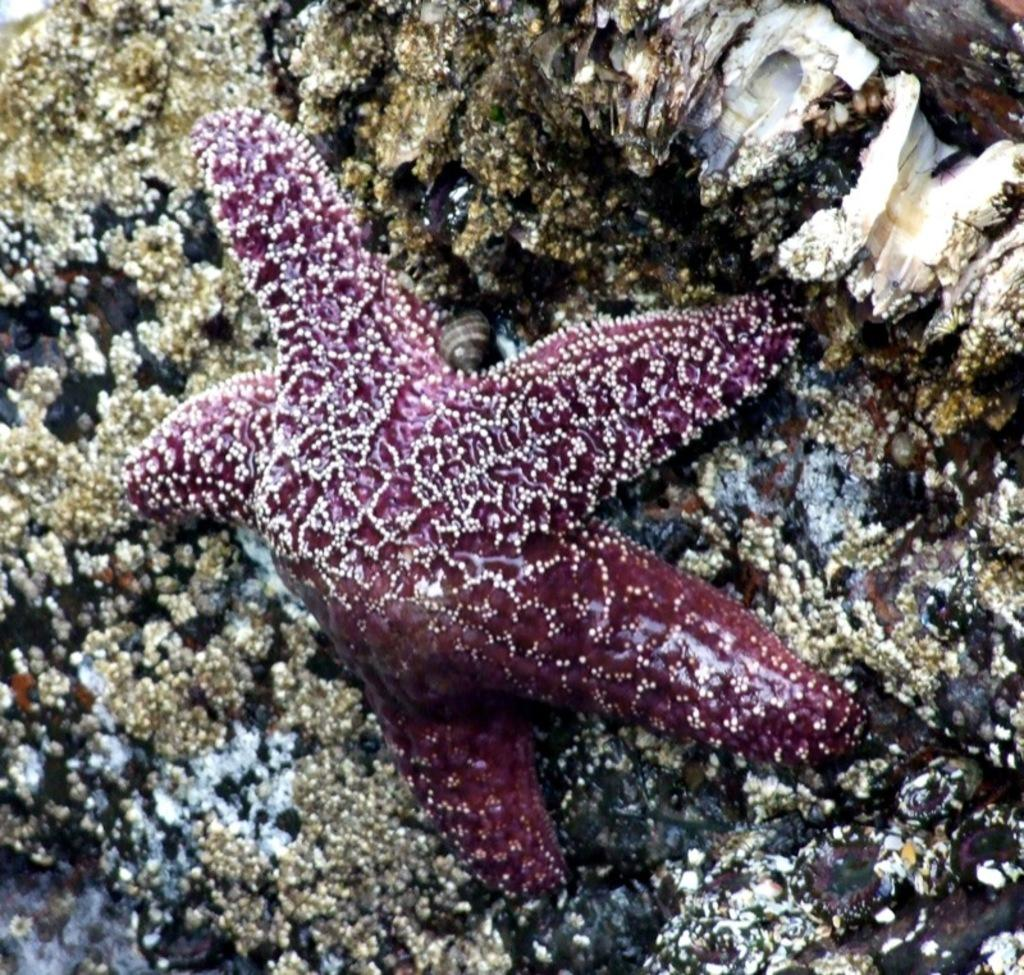What type of marine animal is present in the image? There is a starfish in the image. What type of island can be seen in the background of the image? There is no island present in the image; it only features a starfish. 